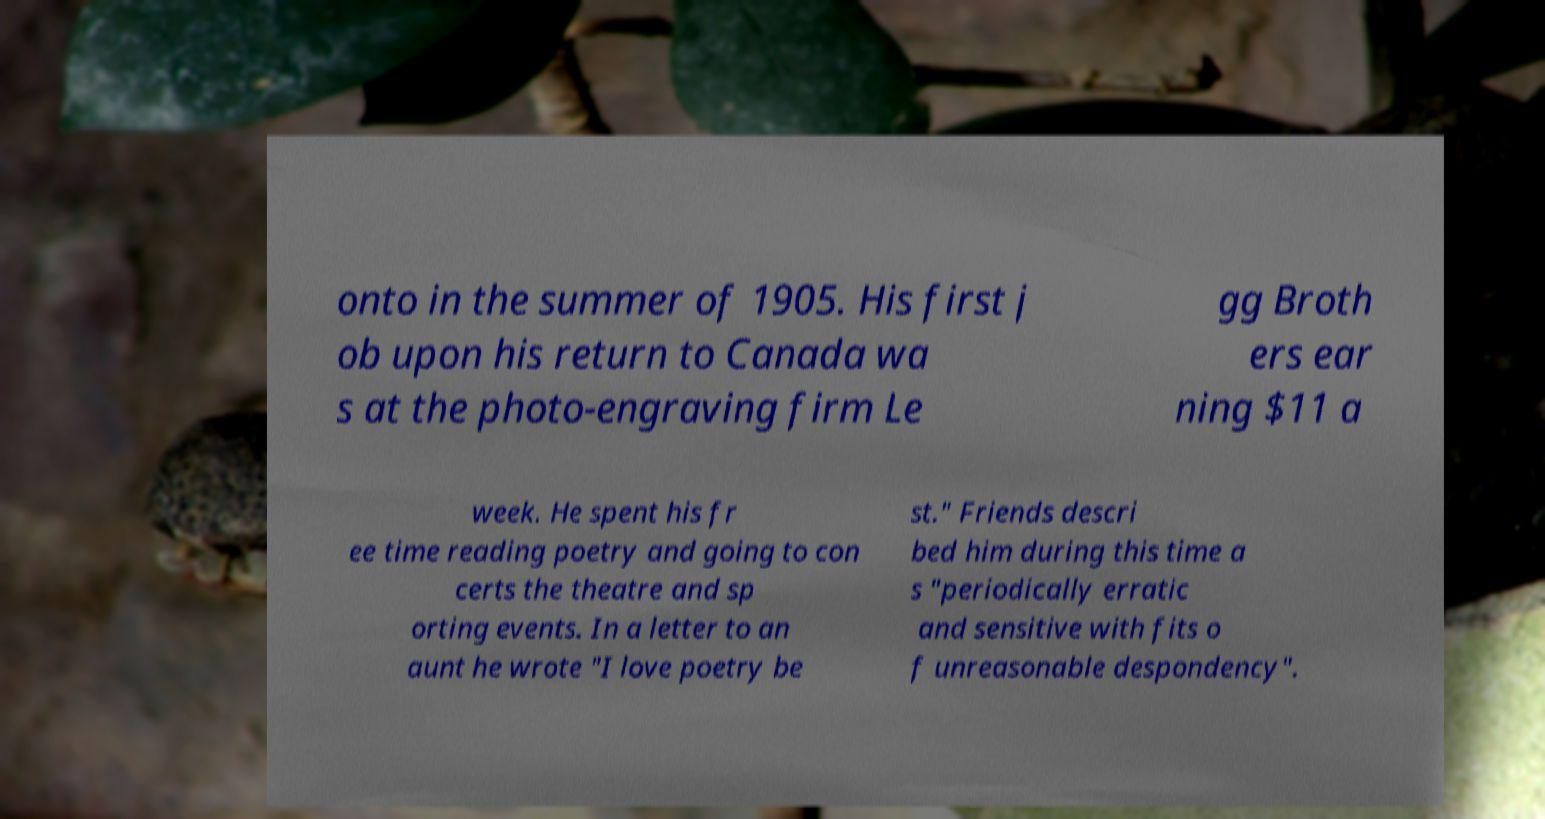Please identify and transcribe the text found in this image. onto in the summer of 1905. His first j ob upon his return to Canada wa s at the photo-engraving firm Le gg Broth ers ear ning $11 a week. He spent his fr ee time reading poetry and going to con certs the theatre and sp orting events. In a letter to an aunt he wrote "I love poetry be st." Friends descri bed him during this time a s "periodically erratic and sensitive with fits o f unreasonable despondency". 